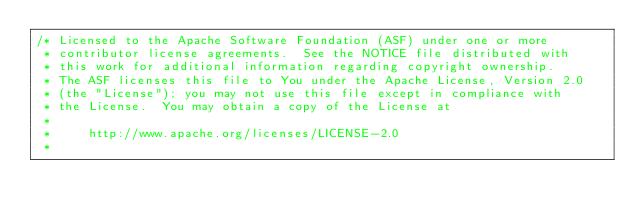Convert code to text. <code><loc_0><loc_0><loc_500><loc_500><_C_>/* Licensed to the Apache Software Foundation (ASF) under one or more
 * contributor license agreements.  See the NOTICE file distributed with
 * this work for additional information regarding copyright ownership.
 * The ASF licenses this file to You under the Apache License, Version 2.0
 * (the "License"); you may not use this file except in compliance with
 * the License.  You may obtain a copy of the License at
 *
 *     http://www.apache.org/licenses/LICENSE-2.0
 *</code> 